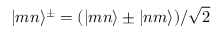Convert formula to latex. <formula><loc_0><loc_0><loc_500><loc_500>| m n \rangle ^ { \pm } = ( | m n \rangle \pm | n m \rangle ) / \sqrt { 2 }</formula> 